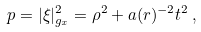<formula> <loc_0><loc_0><loc_500><loc_500>p = | \xi | ^ { 2 } _ { g _ { x } } = \rho ^ { 2 } + a ( r ) ^ { - 2 } t ^ { 2 } \, ,</formula> 